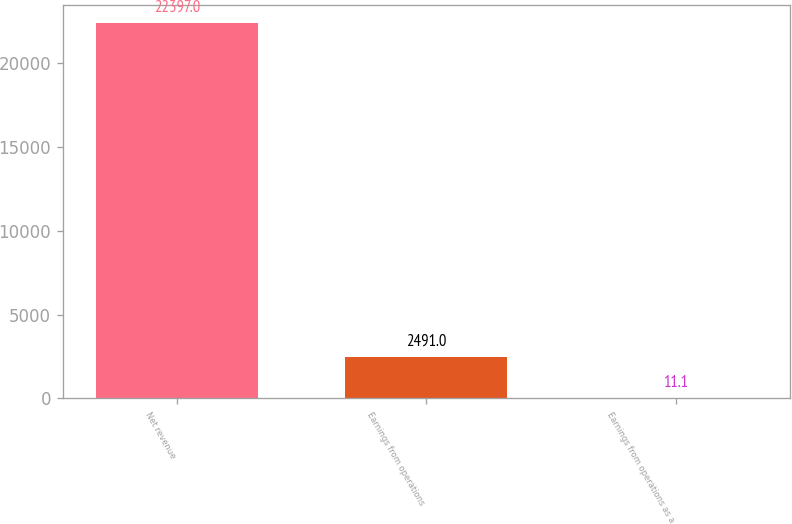Convert chart. <chart><loc_0><loc_0><loc_500><loc_500><bar_chart><fcel>Net revenue<fcel>Earnings from operations<fcel>Earnings from operations as a<nl><fcel>22397<fcel>2491<fcel>11.1<nl></chart> 